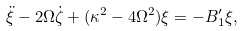<formula> <loc_0><loc_0><loc_500><loc_500>\ddot { \xi } - 2 \Omega \dot { \zeta } + ( \kappa ^ { 2 } - 4 \Omega ^ { 2 } ) \xi = - B _ { 1 } ^ { \prime } \xi ,</formula> 